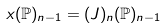Convert formula to latex. <formula><loc_0><loc_0><loc_500><loc_500>x ( \mathbb { P } ) _ { n - 1 } = ( J ) _ { n } ( \mathbb { P } ) _ { n - 1 }</formula> 